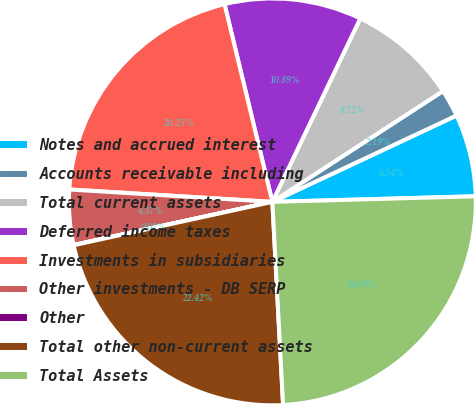Convert chart. <chart><loc_0><loc_0><loc_500><loc_500><pie_chart><fcel>Notes and accrued interest<fcel>Accounts receivable including<fcel>Total current assets<fcel>Deferred income taxes<fcel>Investments in subsidiaries<fcel>Other investments - DB SERP<fcel>Other<fcel>Total other non-current assets<fcel>Total Assets<nl><fcel>6.54%<fcel>2.19%<fcel>8.72%<fcel>10.89%<fcel>20.25%<fcel>4.37%<fcel>0.02%<fcel>22.42%<fcel>24.6%<nl></chart> 